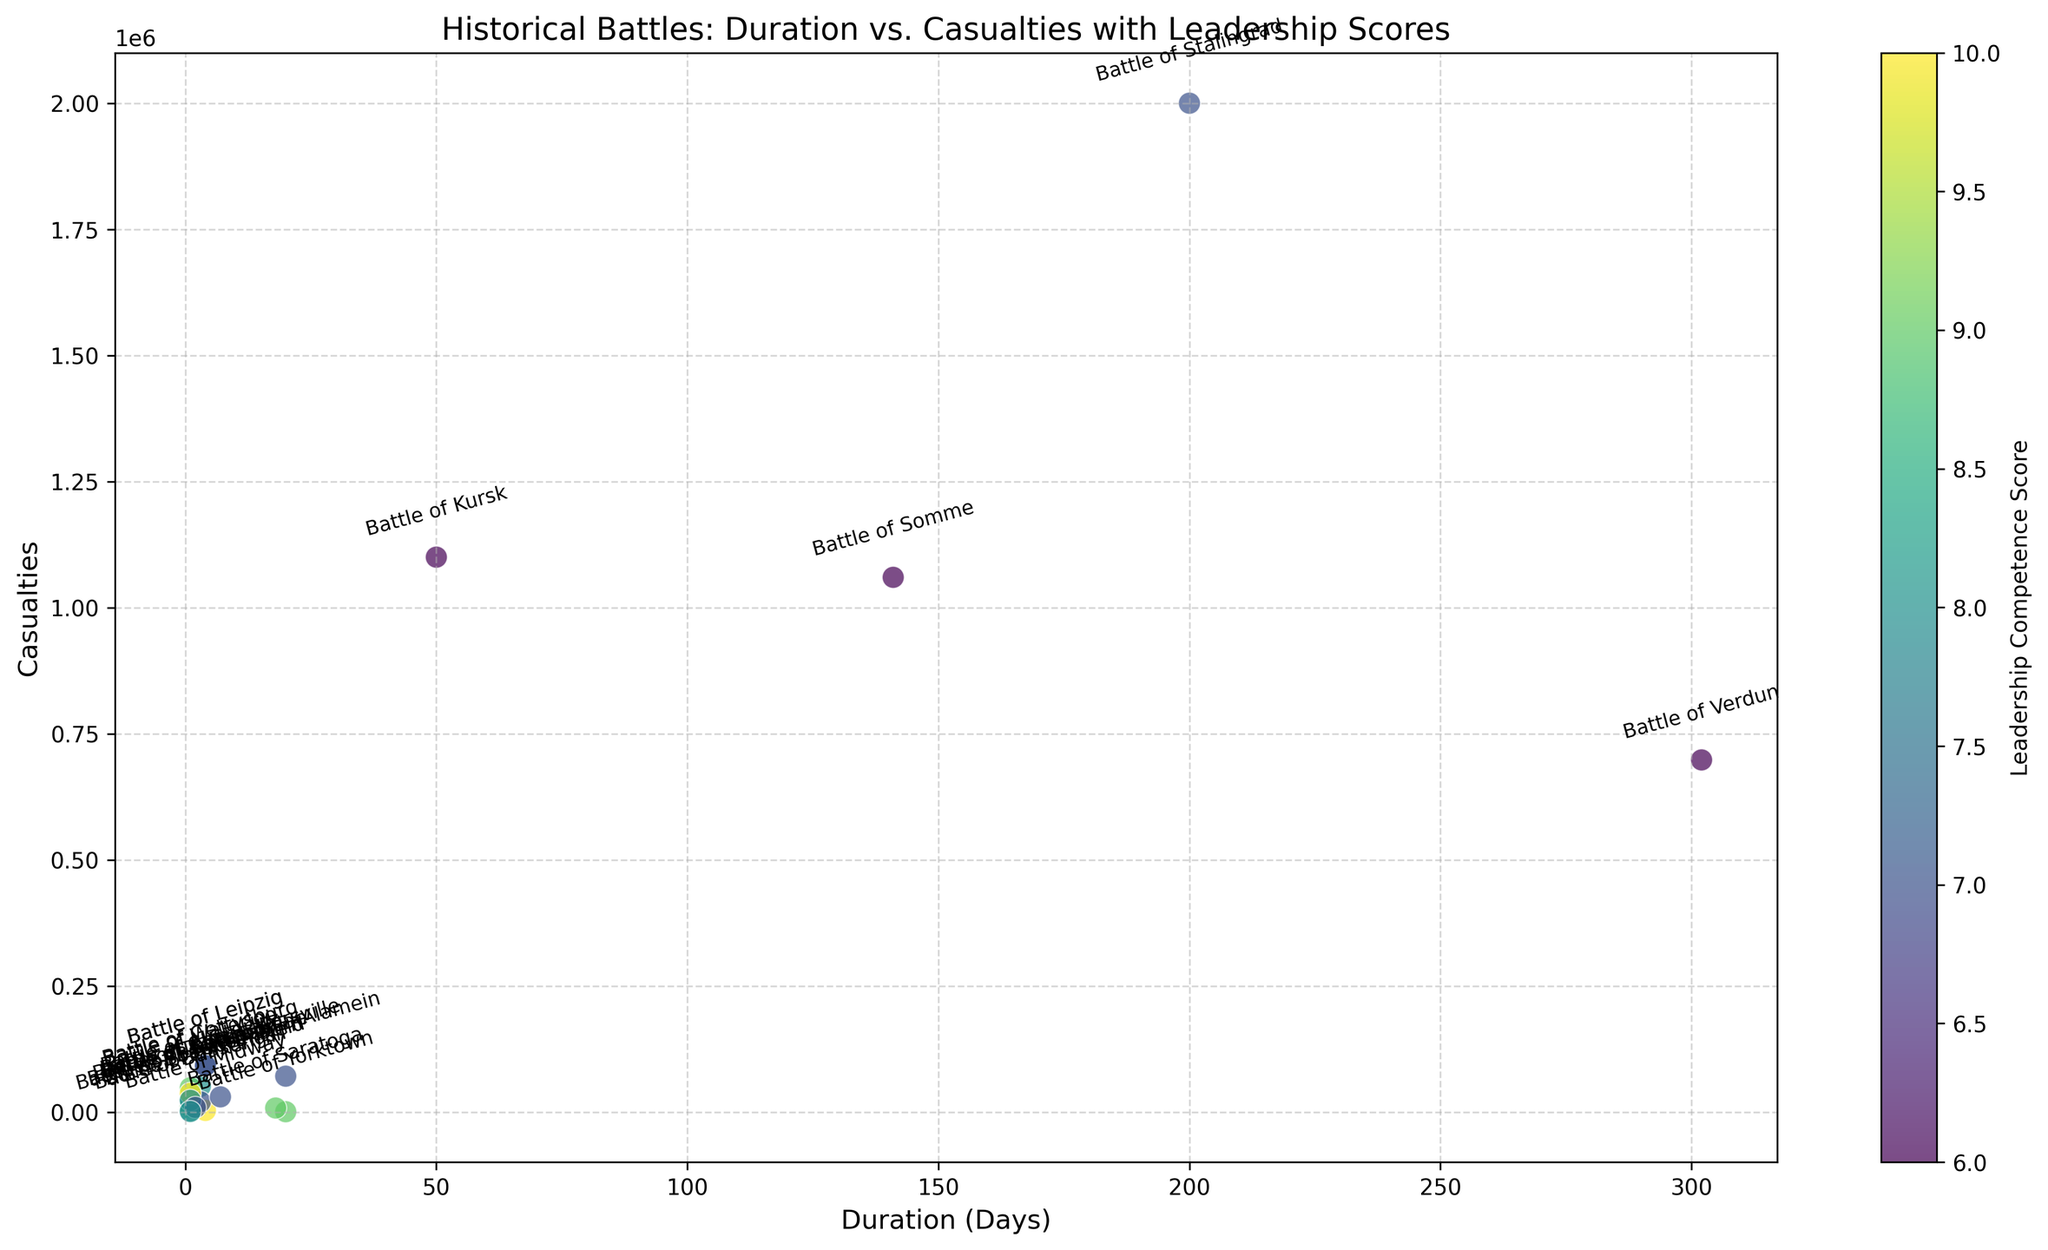What battle had the highest number of casualties? To find the battle with the highest number of casualties, look at the y-axis for the maximum point. The highest point on the y-axis corresponds to the Battle of Stalingrad.
Answer: Battle of Stalingrad How does the duration of the Battle of Midway compare to the Battle of El Alamein? The x-axis represents the duration in days. The scatter point for the Battle of Midway is at 4 days, and for the Battle of El Alamein is at 20 days. Thus, the Battle of Midway is shorter.
Answer: Battle of Midway is shorter Which battle with a duration less than 10 days had the highest leadership competence score? Look for points where the x-axis value is less than 10 days, then check the color intensity representing the leadership competence score. The Battle of Austerlitz has the highest score of 10.
Answer: Battle of Austerlitz What is the total duration of the Battle of Verdun and the Battle of Thermopylae? Add the x-axis values of the Battle of Verdun (302 days) and the Battle of Thermopylae (3 days).
Answer: 305 days Which battle has a similar number of casualties as the Battle of Bannockburn but lasted longer in duration? Identify the y-axis value of the Battle of Bannockburn (9072 casualties) and find another point with a similar y-value but a larger x-value (duration). The Battle of Saratoga fits this description.
Answer: Battle of Saratoga Are there any battles that lasted exactly one day but had different leadership competence scores? Look at points on the x-axis at 1 day and compare their colors. The Battle of Waterloo, Battle of Hastings, Battle of Antietam, Battle of Bunker Hill, Battle of Austerlitz, Battle of Agincourt, and Battle of Bosworth Field all lasted one day with different scores.
Answer: Yes, multiple battles How does the Battle of Gettysburg’s duration compare to the Battle of Yorktown’s? The x-axis positions for the Battle of Gettysburg and the Battle of Yorktown are 3 days and 20 days, respectively. Yorktown lasted longer.
Answer: Yorktown lasted longer 